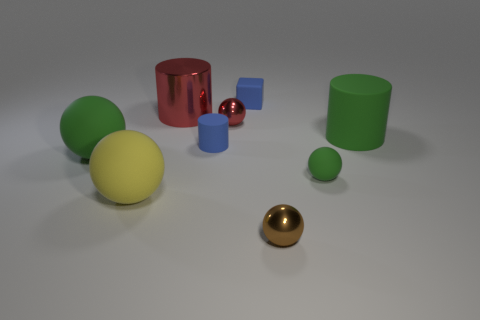Subtract 1 balls. How many balls are left? 4 Subtract all red spheres. How many spheres are left? 4 Subtract all blue spheres. Subtract all red cylinders. How many spheres are left? 5 Subtract all cubes. How many objects are left? 8 Add 2 gray things. How many gray things exist? 2 Subtract 0 green cubes. How many objects are left? 9 Subtract all large red shiny cylinders. Subtract all brown objects. How many objects are left? 7 Add 7 green cylinders. How many green cylinders are left? 8 